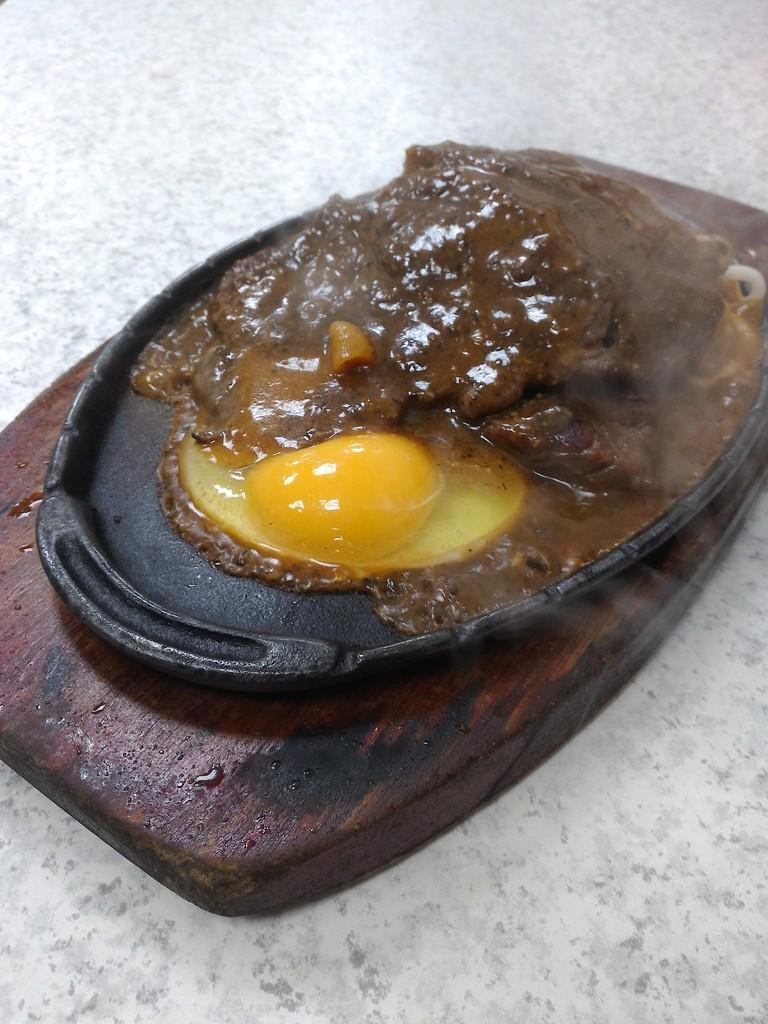What type of food is served on the sizzler in the image? The specific type of food served on the sizzler is not mentioned in the facts, but we know that it is a food item. Where is the sizzler located in the image? The sizzler is placed on a table in the image. What type of experience does the vessel in the image provide? There is no vessel present in the image, so it is not possible to answer a question about an experience it might provide. 